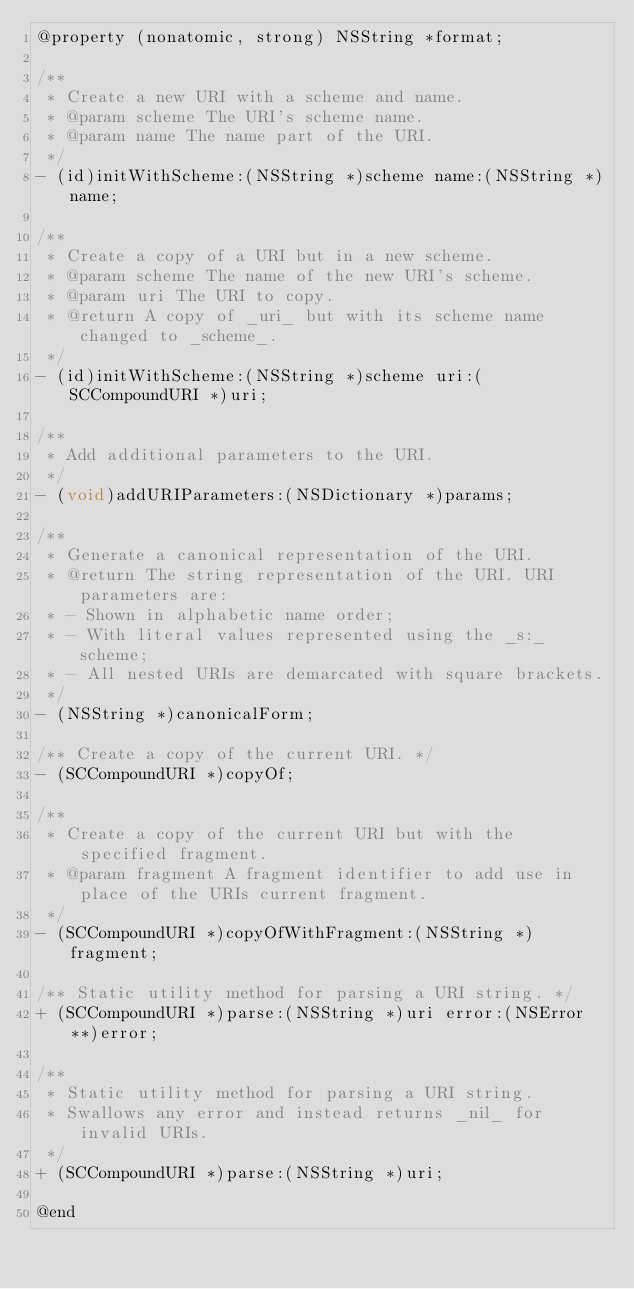Convert code to text. <code><loc_0><loc_0><loc_500><loc_500><_C_>@property (nonatomic, strong) NSString *format;

/**
 * Create a new URI with a scheme and name.
 * @param scheme The URI's scheme name.
 * @param name The name part of the URI.
 */
- (id)initWithScheme:(NSString *)scheme name:(NSString *)name;

/**
 * Create a copy of a URI but in a new scheme.
 * @param scheme The name of the new URI's scheme.
 * @param uri The URI to copy.
 * @return A copy of _uri_ but with its scheme name changed to _scheme_.
 */
- (id)initWithScheme:(NSString *)scheme uri:(SCCompoundURI *)uri;

/**
 * Add additional parameters to the URI.
 */
- (void)addURIParameters:(NSDictionary *)params;

/**
 * Generate a canonical representation of the URI.
 * @return The string representation of the URI. URI parameters are:
 * - Shown in alphabetic name order;
 * - With literal values represented using the _s:_ scheme;
 * - All nested URIs are demarcated with square brackets.
 */
- (NSString *)canonicalForm;

/** Create a copy of the current URI. */
- (SCCompoundURI *)copyOf;

/**
 * Create a copy of the current URI but with the specified fragment.
 * @param fragment A fragment identifier to add use in place of the URIs current fragment.
 */
- (SCCompoundURI *)copyOfWithFragment:(NSString *)fragment;

/** Static utility method for parsing a URI string. */
+ (SCCompoundURI *)parse:(NSString *)uri error:(NSError **)error;

/**
 * Static utility method for parsing a URI string.
 * Swallows any error and instead returns _nil_ for invalid URIs.
 */
+ (SCCompoundURI *)parse:(NSString *)uri;

@end
</code> 